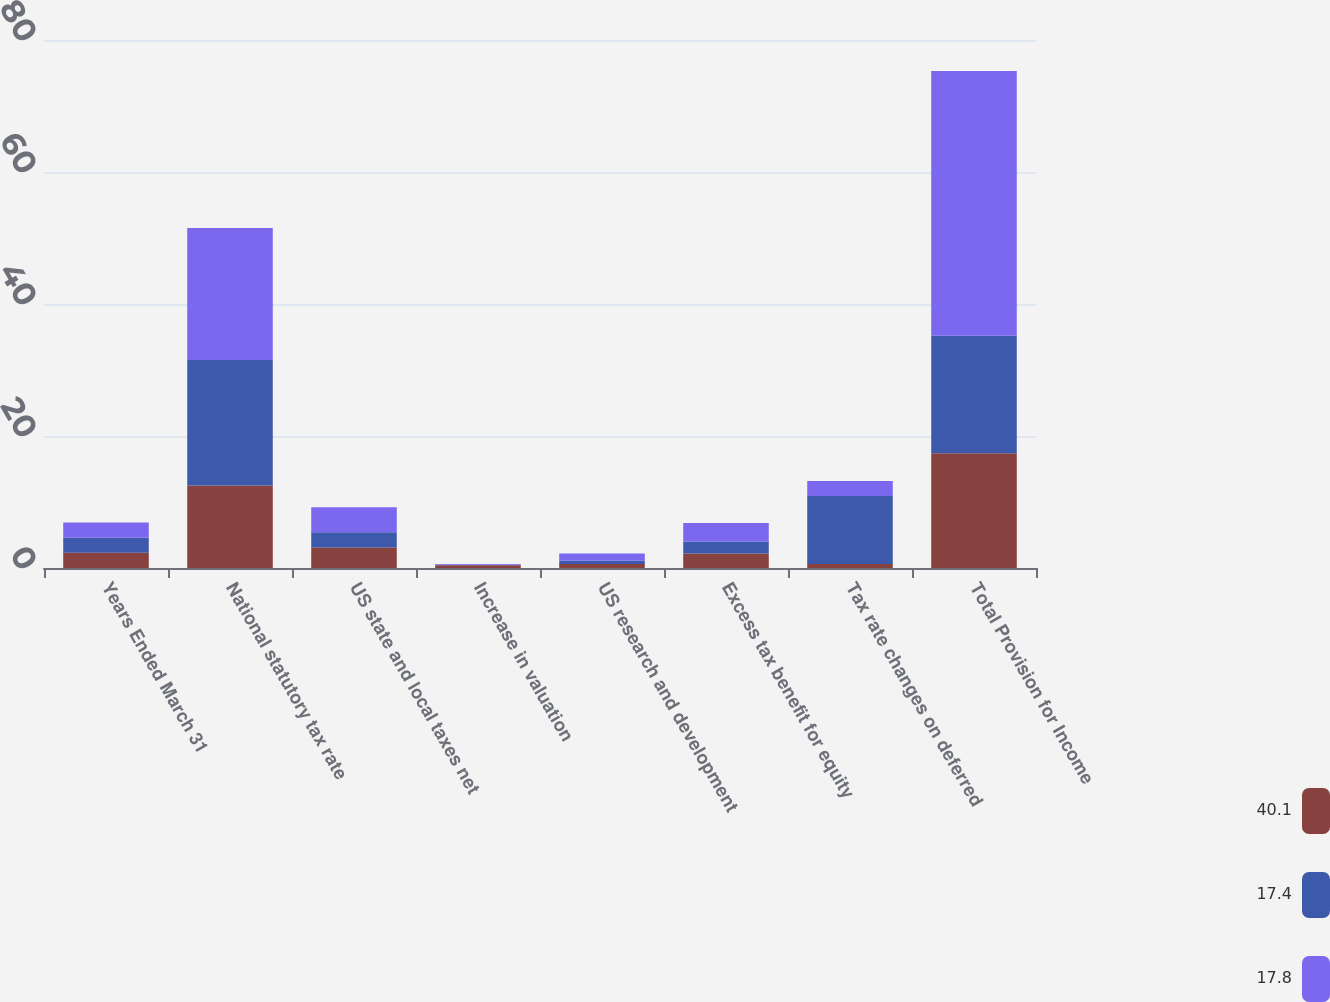Convert chart to OTSL. <chart><loc_0><loc_0><loc_500><loc_500><stacked_bar_chart><ecel><fcel>Years Ended March 31<fcel>National statutory tax rate<fcel>US state and local taxes net<fcel>Increase in valuation<fcel>US research and development<fcel>Excess tax benefit for equity<fcel>Tax rate changes on deferred<fcel>Total Provision for Income<nl><fcel>40.1<fcel>2.3<fcel>12.5<fcel>3.1<fcel>0.4<fcel>0.6<fcel>2.2<fcel>0.6<fcel>17.4<nl><fcel>17.4<fcel>2.3<fcel>19<fcel>2.3<fcel>0.1<fcel>0.5<fcel>1.8<fcel>10.3<fcel>17.8<nl><fcel>17.8<fcel>2.3<fcel>20<fcel>3.8<fcel>0.1<fcel>1.1<fcel>2.8<fcel>2.3<fcel>40.1<nl></chart> 